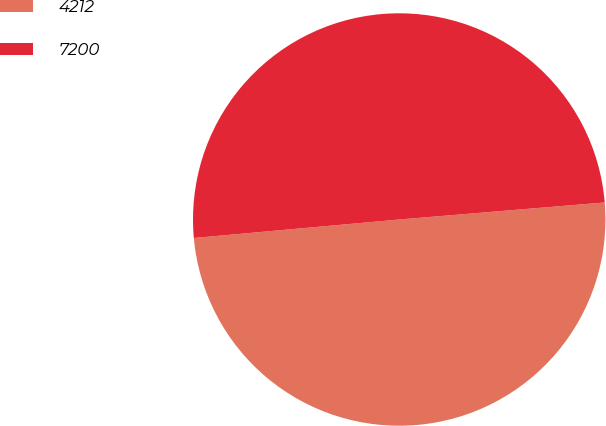Convert chart to OTSL. <chart><loc_0><loc_0><loc_500><loc_500><pie_chart><fcel>4212<fcel>7200<nl><fcel>49.89%<fcel>50.11%<nl></chart> 